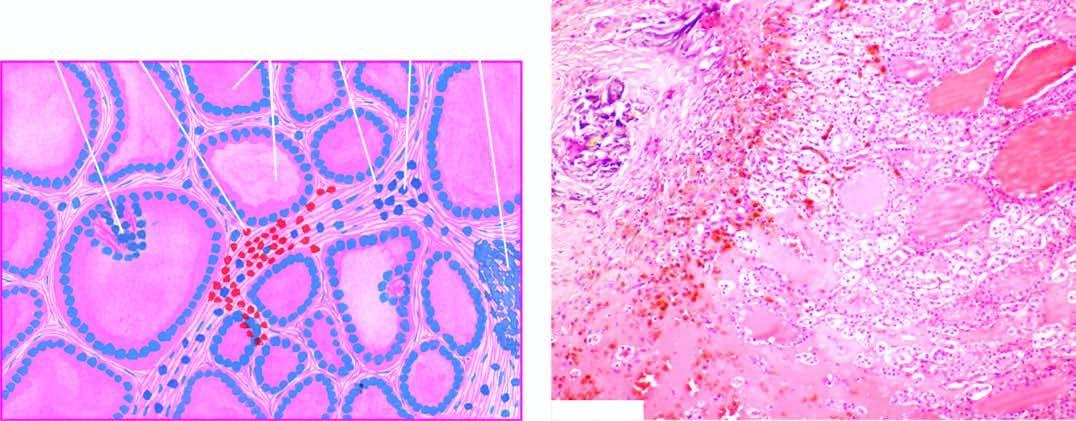what are the predominant histologic features?
Answer the question using a single word or phrase. Nodularity 